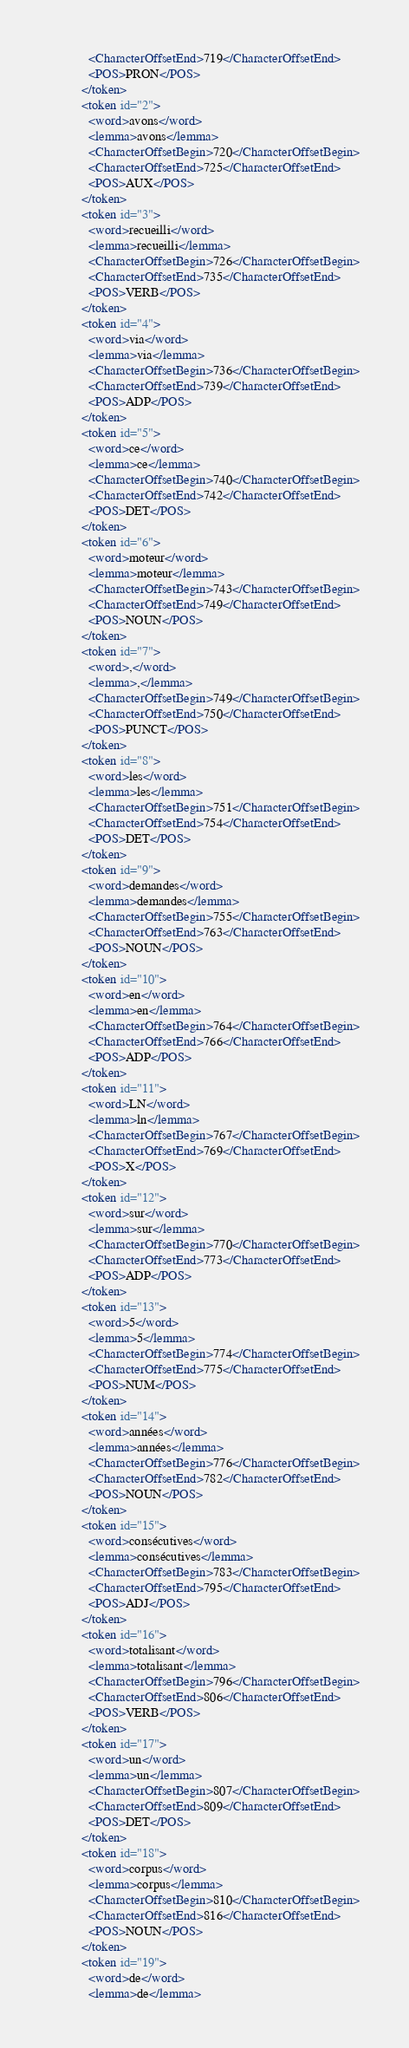Convert code to text. <code><loc_0><loc_0><loc_500><loc_500><_XML_>            <CharacterOffsetEnd>719</CharacterOffsetEnd>
            <POS>PRON</POS>
          </token>
          <token id="2">
            <word>avons</word>
            <lemma>avons</lemma>
            <CharacterOffsetBegin>720</CharacterOffsetBegin>
            <CharacterOffsetEnd>725</CharacterOffsetEnd>
            <POS>AUX</POS>
          </token>
          <token id="3">
            <word>recueilli</word>
            <lemma>recueilli</lemma>
            <CharacterOffsetBegin>726</CharacterOffsetBegin>
            <CharacterOffsetEnd>735</CharacterOffsetEnd>
            <POS>VERB</POS>
          </token>
          <token id="4">
            <word>via</word>
            <lemma>via</lemma>
            <CharacterOffsetBegin>736</CharacterOffsetBegin>
            <CharacterOffsetEnd>739</CharacterOffsetEnd>
            <POS>ADP</POS>
          </token>
          <token id="5">
            <word>ce</word>
            <lemma>ce</lemma>
            <CharacterOffsetBegin>740</CharacterOffsetBegin>
            <CharacterOffsetEnd>742</CharacterOffsetEnd>
            <POS>DET</POS>
          </token>
          <token id="6">
            <word>moteur</word>
            <lemma>moteur</lemma>
            <CharacterOffsetBegin>743</CharacterOffsetBegin>
            <CharacterOffsetEnd>749</CharacterOffsetEnd>
            <POS>NOUN</POS>
          </token>
          <token id="7">
            <word>,</word>
            <lemma>,</lemma>
            <CharacterOffsetBegin>749</CharacterOffsetBegin>
            <CharacterOffsetEnd>750</CharacterOffsetEnd>
            <POS>PUNCT</POS>
          </token>
          <token id="8">
            <word>les</word>
            <lemma>les</lemma>
            <CharacterOffsetBegin>751</CharacterOffsetBegin>
            <CharacterOffsetEnd>754</CharacterOffsetEnd>
            <POS>DET</POS>
          </token>
          <token id="9">
            <word>demandes</word>
            <lemma>demandes</lemma>
            <CharacterOffsetBegin>755</CharacterOffsetBegin>
            <CharacterOffsetEnd>763</CharacterOffsetEnd>
            <POS>NOUN</POS>
          </token>
          <token id="10">
            <word>en</word>
            <lemma>en</lemma>
            <CharacterOffsetBegin>764</CharacterOffsetBegin>
            <CharacterOffsetEnd>766</CharacterOffsetEnd>
            <POS>ADP</POS>
          </token>
          <token id="11">
            <word>LN</word>
            <lemma>ln</lemma>
            <CharacterOffsetBegin>767</CharacterOffsetBegin>
            <CharacterOffsetEnd>769</CharacterOffsetEnd>
            <POS>X</POS>
          </token>
          <token id="12">
            <word>sur</word>
            <lemma>sur</lemma>
            <CharacterOffsetBegin>770</CharacterOffsetBegin>
            <CharacterOffsetEnd>773</CharacterOffsetEnd>
            <POS>ADP</POS>
          </token>
          <token id="13">
            <word>5</word>
            <lemma>5</lemma>
            <CharacterOffsetBegin>774</CharacterOffsetBegin>
            <CharacterOffsetEnd>775</CharacterOffsetEnd>
            <POS>NUM</POS>
          </token>
          <token id="14">
            <word>années</word>
            <lemma>années</lemma>
            <CharacterOffsetBegin>776</CharacterOffsetBegin>
            <CharacterOffsetEnd>782</CharacterOffsetEnd>
            <POS>NOUN</POS>
          </token>
          <token id="15">
            <word>consécutives</word>
            <lemma>consécutives</lemma>
            <CharacterOffsetBegin>783</CharacterOffsetBegin>
            <CharacterOffsetEnd>795</CharacterOffsetEnd>
            <POS>ADJ</POS>
          </token>
          <token id="16">
            <word>totalisant</word>
            <lemma>totalisant</lemma>
            <CharacterOffsetBegin>796</CharacterOffsetBegin>
            <CharacterOffsetEnd>806</CharacterOffsetEnd>
            <POS>VERB</POS>
          </token>
          <token id="17">
            <word>un</word>
            <lemma>un</lemma>
            <CharacterOffsetBegin>807</CharacterOffsetBegin>
            <CharacterOffsetEnd>809</CharacterOffsetEnd>
            <POS>DET</POS>
          </token>
          <token id="18">
            <word>corpus</word>
            <lemma>corpus</lemma>
            <CharacterOffsetBegin>810</CharacterOffsetBegin>
            <CharacterOffsetEnd>816</CharacterOffsetEnd>
            <POS>NOUN</POS>
          </token>
          <token id="19">
            <word>de</word>
            <lemma>de</lemma></code> 